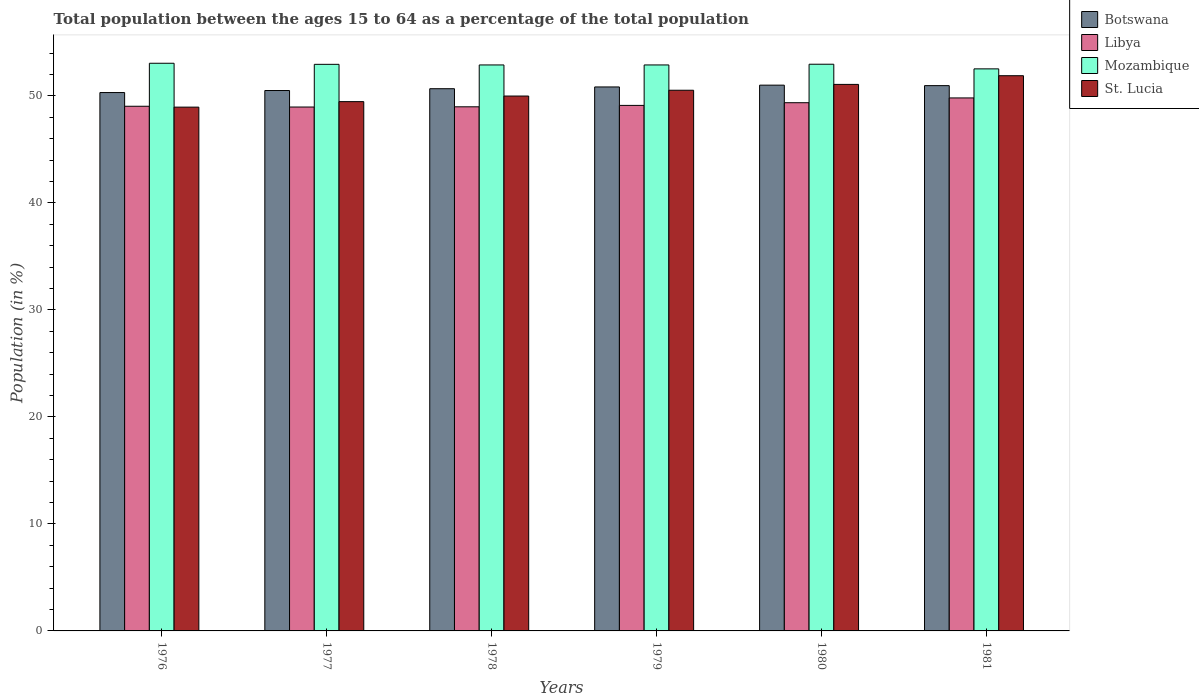How many different coloured bars are there?
Offer a terse response. 4. How many bars are there on the 6th tick from the right?
Your answer should be very brief. 4. What is the label of the 4th group of bars from the left?
Your answer should be compact. 1979. In how many cases, is the number of bars for a given year not equal to the number of legend labels?
Offer a very short reply. 0. What is the percentage of the population ages 15 to 64 in Mozambique in 1976?
Your answer should be compact. 53.05. Across all years, what is the maximum percentage of the population ages 15 to 64 in Libya?
Your answer should be compact. 49.81. Across all years, what is the minimum percentage of the population ages 15 to 64 in Mozambique?
Ensure brevity in your answer.  52.53. In which year was the percentage of the population ages 15 to 64 in Libya maximum?
Give a very brief answer. 1981. What is the total percentage of the population ages 15 to 64 in St. Lucia in the graph?
Provide a short and direct response. 301.91. What is the difference between the percentage of the population ages 15 to 64 in Libya in 1978 and that in 1979?
Offer a very short reply. -0.13. What is the difference between the percentage of the population ages 15 to 64 in Mozambique in 1977 and the percentage of the population ages 15 to 64 in Botswana in 1978?
Your answer should be compact. 2.28. What is the average percentage of the population ages 15 to 64 in St. Lucia per year?
Provide a succinct answer. 50.32. In the year 1977, what is the difference between the percentage of the population ages 15 to 64 in Botswana and percentage of the population ages 15 to 64 in St. Lucia?
Your answer should be compact. 1.04. In how many years, is the percentage of the population ages 15 to 64 in St. Lucia greater than 46?
Keep it short and to the point. 6. What is the ratio of the percentage of the population ages 15 to 64 in Mozambique in 1978 to that in 1981?
Offer a terse response. 1.01. What is the difference between the highest and the second highest percentage of the population ages 15 to 64 in Botswana?
Offer a very short reply. 0.05. What is the difference between the highest and the lowest percentage of the population ages 15 to 64 in Mozambique?
Provide a short and direct response. 0.52. In how many years, is the percentage of the population ages 15 to 64 in Mozambique greater than the average percentage of the population ages 15 to 64 in Mozambique taken over all years?
Make the answer very short. 5. Is it the case that in every year, the sum of the percentage of the population ages 15 to 64 in St. Lucia and percentage of the population ages 15 to 64 in Libya is greater than the sum of percentage of the population ages 15 to 64 in Botswana and percentage of the population ages 15 to 64 in Mozambique?
Your answer should be very brief. No. What does the 1st bar from the left in 1979 represents?
Keep it short and to the point. Botswana. What does the 3rd bar from the right in 1980 represents?
Your response must be concise. Libya. Is it the case that in every year, the sum of the percentage of the population ages 15 to 64 in St. Lucia and percentage of the population ages 15 to 64 in Libya is greater than the percentage of the population ages 15 to 64 in Mozambique?
Your answer should be compact. Yes. How many bars are there?
Your response must be concise. 24. What is the difference between two consecutive major ticks on the Y-axis?
Your answer should be very brief. 10. Are the values on the major ticks of Y-axis written in scientific E-notation?
Make the answer very short. No. What is the title of the graph?
Your response must be concise. Total population between the ages 15 to 64 as a percentage of the total population. Does "Albania" appear as one of the legend labels in the graph?
Provide a short and direct response. No. What is the label or title of the X-axis?
Provide a short and direct response. Years. What is the label or title of the Y-axis?
Ensure brevity in your answer.  Population (in %). What is the Population (in %) of Botswana in 1976?
Your response must be concise. 50.32. What is the Population (in %) in Libya in 1976?
Your response must be concise. 49.03. What is the Population (in %) in Mozambique in 1976?
Offer a terse response. 53.05. What is the Population (in %) of St. Lucia in 1976?
Keep it short and to the point. 48.95. What is the Population (in %) in Botswana in 1977?
Your answer should be compact. 50.51. What is the Population (in %) of Libya in 1977?
Your answer should be very brief. 48.96. What is the Population (in %) in Mozambique in 1977?
Provide a short and direct response. 52.95. What is the Population (in %) in St. Lucia in 1977?
Your response must be concise. 49.47. What is the Population (in %) of Botswana in 1978?
Your response must be concise. 50.68. What is the Population (in %) of Libya in 1978?
Give a very brief answer. 48.98. What is the Population (in %) in Mozambique in 1978?
Provide a succinct answer. 52.9. What is the Population (in %) of St. Lucia in 1978?
Your response must be concise. 49.99. What is the Population (in %) in Botswana in 1979?
Provide a succinct answer. 50.84. What is the Population (in %) in Libya in 1979?
Make the answer very short. 49.12. What is the Population (in %) in Mozambique in 1979?
Your answer should be very brief. 52.9. What is the Population (in %) in St. Lucia in 1979?
Ensure brevity in your answer.  50.53. What is the Population (in %) of Botswana in 1980?
Provide a succinct answer. 51.01. What is the Population (in %) in Libya in 1980?
Ensure brevity in your answer.  49.37. What is the Population (in %) in Mozambique in 1980?
Make the answer very short. 52.96. What is the Population (in %) in St. Lucia in 1980?
Offer a very short reply. 51.08. What is the Population (in %) of Botswana in 1981?
Offer a terse response. 50.96. What is the Population (in %) in Libya in 1981?
Offer a very short reply. 49.81. What is the Population (in %) in Mozambique in 1981?
Offer a very short reply. 52.53. What is the Population (in %) of St. Lucia in 1981?
Give a very brief answer. 51.89. Across all years, what is the maximum Population (in %) in Botswana?
Provide a short and direct response. 51.01. Across all years, what is the maximum Population (in %) of Libya?
Ensure brevity in your answer.  49.81. Across all years, what is the maximum Population (in %) in Mozambique?
Offer a very short reply. 53.05. Across all years, what is the maximum Population (in %) in St. Lucia?
Give a very brief answer. 51.89. Across all years, what is the minimum Population (in %) in Botswana?
Offer a terse response. 50.32. Across all years, what is the minimum Population (in %) of Libya?
Your answer should be compact. 48.96. Across all years, what is the minimum Population (in %) in Mozambique?
Give a very brief answer. 52.53. Across all years, what is the minimum Population (in %) of St. Lucia?
Give a very brief answer. 48.95. What is the total Population (in %) in Botswana in the graph?
Provide a short and direct response. 304.31. What is the total Population (in %) in Libya in the graph?
Ensure brevity in your answer.  295.28. What is the total Population (in %) of Mozambique in the graph?
Offer a very short reply. 317.29. What is the total Population (in %) in St. Lucia in the graph?
Offer a terse response. 301.91. What is the difference between the Population (in %) of Botswana in 1976 and that in 1977?
Provide a short and direct response. -0.19. What is the difference between the Population (in %) in Libya in 1976 and that in 1977?
Give a very brief answer. 0.07. What is the difference between the Population (in %) in Mozambique in 1976 and that in 1977?
Keep it short and to the point. 0.1. What is the difference between the Population (in %) in St. Lucia in 1976 and that in 1977?
Your answer should be compact. -0.51. What is the difference between the Population (in %) in Botswana in 1976 and that in 1978?
Offer a terse response. -0.36. What is the difference between the Population (in %) in Libya in 1976 and that in 1978?
Your answer should be compact. 0.05. What is the difference between the Population (in %) of Mozambique in 1976 and that in 1978?
Offer a very short reply. 0.16. What is the difference between the Population (in %) of St. Lucia in 1976 and that in 1978?
Your response must be concise. -1.04. What is the difference between the Population (in %) of Botswana in 1976 and that in 1979?
Your answer should be very brief. -0.52. What is the difference between the Population (in %) in Libya in 1976 and that in 1979?
Your response must be concise. -0.08. What is the difference between the Population (in %) in Mozambique in 1976 and that in 1979?
Provide a succinct answer. 0.16. What is the difference between the Population (in %) of St. Lucia in 1976 and that in 1979?
Provide a succinct answer. -1.58. What is the difference between the Population (in %) of Botswana in 1976 and that in 1980?
Ensure brevity in your answer.  -0.69. What is the difference between the Population (in %) of Libya in 1976 and that in 1980?
Your answer should be very brief. -0.33. What is the difference between the Population (in %) of Mozambique in 1976 and that in 1980?
Give a very brief answer. 0.09. What is the difference between the Population (in %) of St. Lucia in 1976 and that in 1980?
Make the answer very short. -2.13. What is the difference between the Population (in %) in Botswana in 1976 and that in 1981?
Your answer should be very brief. -0.65. What is the difference between the Population (in %) of Libya in 1976 and that in 1981?
Your response must be concise. -0.78. What is the difference between the Population (in %) in Mozambique in 1976 and that in 1981?
Provide a succinct answer. 0.52. What is the difference between the Population (in %) of St. Lucia in 1976 and that in 1981?
Provide a succinct answer. -2.94. What is the difference between the Population (in %) in Botswana in 1977 and that in 1978?
Provide a succinct answer. -0.17. What is the difference between the Population (in %) of Libya in 1977 and that in 1978?
Your response must be concise. -0.02. What is the difference between the Population (in %) in Mozambique in 1977 and that in 1978?
Keep it short and to the point. 0.06. What is the difference between the Population (in %) of St. Lucia in 1977 and that in 1978?
Offer a very short reply. -0.52. What is the difference between the Population (in %) of Botswana in 1977 and that in 1979?
Keep it short and to the point. -0.33. What is the difference between the Population (in %) in Libya in 1977 and that in 1979?
Your response must be concise. -0.15. What is the difference between the Population (in %) in Mozambique in 1977 and that in 1979?
Provide a short and direct response. 0.06. What is the difference between the Population (in %) of St. Lucia in 1977 and that in 1979?
Your answer should be compact. -1.06. What is the difference between the Population (in %) in Botswana in 1977 and that in 1980?
Your answer should be compact. -0.5. What is the difference between the Population (in %) in Libya in 1977 and that in 1980?
Your response must be concise. -0.4. What is the difference between the Population (in %) in Mozambique in 1977 and that in 1980?
Your answer should be compact. -0.01. What is the difference between the Population (in %) in St. Lucia in 1977 and that in 1980?
Give a very brief answer. -1.61. What is the difference between the Population (in %) of Botswana in 1977 and that in 1981?
Ensure brevity in your answer.  -0.46. What is the difference between the Population (in %) of Libya in 1977 and that in 1981?
Provide a succinct answer. -0.85. What is the difference between the Population (in %) of Mozambique in 1977 and that in 1981?
Keep it short and to the point. 0.42. What is the difference between the Population (in %) in St. Lucia in 1977 and that in 1981?
Your answer should be very brief. -2.42. What is the difference between the Population (in %) of Botswana in 1978 and that in 1979?
Your response must be concise. -0.16. What is the difference between the Population (in %) in Libya in 1978 and that in 1979?
Give a very brief answer. -0.13. What is the difference between the Population (in %) of Mozambique in 1978 and that in 1979?
Provide a short and direct response. -0. What is the difference between the Population (in %) of St. Lucia in 1978 and that in 1979?
Your answer should be very brief. -0.54. What is the difference between the Population (in %) of Botswana in 1978 and that in 1980?
Your answer should be compact. -0.33. What is the difference between the Population (in %) in Libya in 1978 and that in 1980?
Give a very brief answer. -0.38. What is the difference between the Population (in %) of Mozambique in 1978 and that in 1980?
Your answer should be compact. -0.07. What is the difference between the Population (in %) of St. Lucia in 1978 and that in 1980?
Your answer should be compact. -1.09. What is the difference between the Population (in %) in Botswana in 1978 and that in 1981?
Your answer should be compact. -0.29. What is the difference between the Population (in %) of Libya in 1978 and that in 1981?
Provide a short and direct response. -0.83. What is the difference between the Population (in %) of Mozambique in 1978 and that in 1981?
Keep it short and to the point. 0.37. What is the difference between the Population (in %) in St. Lucia in 1978 and that in 1981?
Offer a very short reply. -1.9. What is the difference between the Population (in %) of Botswana in 1979 and that in 1980?
Keep it short and to the point. -0.17. What is the difference between the Population (in %) in Libya in 1979 and that in 1980?
Give a very brief answer. -0.25. What is the difference between the Population (in %) of Mozambique in 1979 and that in 1980?
Your answer should be compact. -0.07. What is the difference between the Population (in %) of St. Lucia in 1979 and that in 1980?
Offer a terse response. -0.55. What is the difference between the Population (in %) of Botswana in 1979 and that in 1981?
Give a very brief answer. -0.12. What is the difference between the Population (in %) of Libya in 1979 and that in 1981?
Provide a short and direct response. -0.7. What is the difference between the Population (in %) in Mozambique in 1979 and that in 1981?
Keep it short and to the point. 0.37. What is the difference between the Population (in %) of St. Lucia in 1979 and that in 1981?
Provide a short and direct response. -1.36. What is the difference between the Population (in %) of Botswana in 1980 and that in 1981?
Your response must be concise. 0.05. What is the difference between the Population (in %) in Libya in 1980 and that in 1981?
Give a very brief answer. -0.45. What is the difference between the Population (in %) in Mozambique in 1980 and that in 1981?
Offer a very short reply. 0.43. What is the difference between the Population (in %) of St. Lucia in 1980 and that in 1981?
Your answer should be very brief. -0.81. What is the difference between the Population (in %) in Botswana in 1976 and the Population (in %) in Libya in 1977?
Offer a terse response. 1.35. What is the difference between the Population (in %) in Botswana in 1976 and the Population (in %) in Mozambique in 1977?
Your response must be concise. -2.64. What is the difference between the Population (in %) of Botswana in 1976 and the Population (in %) of St. Lucia in 1977?
Give a very brief answer. 0.85. What is the difference between the Population (in %) in Libya in 1976 and the Population (in %) in Mozambique in 1977?
Ensure brevity in your answer.  -3.92. What is the difference between the Population (in %) of Libya in 1976 and the Population (in %) of St. Lucia in 1977?
Ensure brevity in your answer.  -0.43. What is the difference between the Population (in %) of Mozambique in 1976 and the Population (in %) of St. Lucia in 1977?
Keep it short and to the point. 3.59. What is the difference between the Population (in %) in Botswana in 1976 and the Population (in %) in Libya in 1978?
Your answer should be compact. 1.33. What is the difference between the Population (in %) in Botswana in 1976 and the Population (in %) in Mozambique in 1978?
Your response must be concise. -2.58. What is the difference between the Population (in %) in Botswana in 1976 and the Population (in %) in St. Lucia in 1978?
Give a very brief answer. 0.33. What is the difference between the Population (in %) of Libya in 1976 and the Population (in %) of Mozambique in 1978?
Provide a short and direct response. -3.86. What is the difference between the Population (in %) of Libya in 1976 and the Population (in %) of St. Lucia in 1978?
Ensure brevity in your answer.  -0.96. What is the difference between the Population (in %) of Mozambique in 1976 and the Population (in %) of St. Lucia in 1978?
Give a very brief answer. 3.06. What is the difference between the Population (in %) in Botswana in 1976 and the Population (in %) in Libya in 1979?
Your answer should be very brief. 1.2. What is the difference between the Population (in %) in Botswana in 1976 and the Population (in %) in Mozambique in 1979?
Make the answer very short. -2.58. What is the difference between the Population (in %) in Botswana in 1976 and the Population (in %) in St. Lucia in 1979?
Provide a short and direct response. -0.22. What is the difference between the Population (in %) of Libya in 1976 and the Population (in %) of Mozambique in 1979?
Give a very brief answer. -3.86. What is the difference between the Population (in %) of Libya in 1976 and the Population (in %) of St. Lucia in 1979?
Give a very brief answer. -1.5. What is the difference between the Population (in %) in Mozambique in 1976 and the Population (in %) in St. Lucia in 1979?
Keep it short and to the point. 2.52. What is the difference between the Population (in %) in Botswana in 1976 and the Population (in %) in Libya in 1980?
Your response must be concise. 0.95. What is the difference between the Population (in %) in Botswana in 1976 and the Population (in %) in Mozambique in 1980?
Provide a succinct answer. -2.65. What is the difference between the Population (in %) of Botswana in 1976 and the Population (in %) of St. Lucia in 1980?
Offer a very short reply. -0.76. What is the difference between the Population (in %) in Libya in 1976 and the Population (in %) in Mozambique in 1980?
Ensure brevity in your answer.  -3.93. What is the difference between the Population (in %) of Libya in 1976 and the Population (in %) of St. Lucia in 1980?
Ensure brevity in your answer.  -2.04. What is the difference between the Population (in %) of Mozambique in 1976 and the Population (in %) of St. Lucia in 1980?
Offer a terse response. 1.98. What is the difference between the Population (in %) of Botswana in 1976 and the Population (in %) of Libya in 1981?
Give a very brief answer. 0.5. What is the difference between the Population (in %) of Botswana in 1976 and the Population (in %) of Mozambique in 1981?
Provide a short and direct response. -2.21. What is the difference between the Population (in %) in Botswana in 1976 and the Population (in %) in St. Lucia in 1981?
Your answer should be very brief. -1.57. What is the difference between the Population (in %) in Libya in 1976 and the Population (in %) in Mozambique in 1981?
Your answer should be compact. -3.49. What is the difference between the Population (in %) of Libya in 1976 and the Population (in %) of St. Lucia in 1981?
Ensure brevity in your answer.  -2.86. What is the difference between the Population (in %) in Mozambique in 1976 and the Population (in %) in St. Lucia in 1981?
Give a very brief answer. 1.16. What is the difference between the Population (in %) in Botswana in 1977 and the Population (in %) in Libya in 1978?
Make the answer very short. 1.52. What is the difference between the Population (in %) of Botswana in 1977 and the Population (in %) of Mozambique in 1978?
Make the answer very short. -2.39. What is the difference between the Population (in %) of Botswana in 1977 and the Population (in %) of St. Lucia in 1978?
Keep it short and to the point. 0.52. What is the difference between the Population (in %) of Libya in 1977 and the Population (in %) of Mozambique in 1978?
Your answer should be compact. -3.93. What is the difference between the Population (in %) in Libya in 1977 and the Population (in %) in St. Lucia in 1978?
Your answer should be compact. -1.03. What is the difference between the Population (in %) of Mozambique in 1977 and the Population (in %) of St. Lucia in 1978?
Your answer should be very brief. 2.96. What is the difference between the Population (in %) of Botswana in 1977 and the Population (in %) of Libya in 1979?
Your answer should be very brief. 1.39. What is the difference between the Population (in %) in Botswana in 1977 and the Population (in %) in Mozambique in 1979?
Offer a very short reply. -2.39. What is the difference between the Population (in %) of Botswana in 1977 and the Population (in %) of St. Lucia in 1979?
Offer a terse response. -0.03. What is the difference between the Population (in %) of Libya in 1977 and the Population (in %) of Mozambique in 1979?
Offer a very short reply. -3.93. What is the difference between the Population (in %) in Libya in 1977 and the Population (in %) in St. Lucia in 1979?
Give a very brief answer. -1.57. What is the difference between the Population (in %) of Mozambique in 1977 and the Population (in %) of St. Lucia in 1979?
Your response must be concise. 2.42. What is the difference between the Population (in %) of Botswana in 1977 and the Population (in %) of Libya in 1980?
Your answer should be compact. 1.14. What is the difference between the Population (in %) in Botswana in 1977 and the Population (in %) in Mozambique in 1980?
Your answer should be compact. -2.46. What is the difference between the Population (in %) of Botswana in 1977 and the Population (in %) of St. Lucia in 1980?
Offer a very short reply. -0.57. What is the difference between the Population (in %) in Libya in 1977 and the Population (in %) in Mozambique in 1980?
Make the answer very short. -4. What is the difference between the Population (in %) in Libya in 1977 and the Population (in %) in St. Lucia in 1980?
Provide a short and direct response. -2.11. What is the difference between the Population (in %) in Mozambique in 1977 and the Population (in %) in St. Lucia in 1980?
Your response must be concise. 1.88. What is the difference between the Population (in %) of Botswana in 1977 and the Population (in %) of Libya in 1981?
Offer a terse response. 0.69. What is the difference between the Population (in %) of Botswana in 1977 and the Population (in %) of Mozambique in 1981?
Your answer should be very brief. -2.02. What is the difference between the Population (in %) in Botswana in 1977 and the Population (in %) in St. Lucia in 1981?
Offer a very short reply. -1.38. What is the difference between the Population (in %) in Libya in 1977 and the Population (in %) in Mozambique in 1981?
Keep it short and to the point. -3.57. What is the difference between the Population (in %) of Libya in 1977 and the Population (in %) of St. Lucia in 1981?
Make the answer very short. -2.93. What is the difference between the Population (in %) in Mozambique in 1977 and the Population (in %) in St. Lucia in 1981?
Your answer should be compact. 1.06. What is the difference between the Population (in %) of Botswana in 1978 and the Population (in %) of Libya in 1979?
Provide a succinct answer. 1.56. What is the difference between the Population (in %) of Botswana in 1978 and the Population (in %) of Mozambique in 1979?
Your answer should be compact. -2.22. What is the difference between the Population (in %) of Botswana in 1978 and the Population (in %) of St. Lucia in 1979?
Provide a short and direct response. 0.14. What is the difference between the Population (in %) of Libya in 1978 and the Population (in %) of Mozambique in 1979?
Your answer should be compact. -3.91. What is the difference between the Population (in %) of Libya in 1978 and the Population (in %) of St. Lucia in 1979?
Provide a succinct answer. -1.55. What is the difference between the Population (in %) in Mozambique in 1978 and the Population (in %) in St. Lucia in 1979?
Offer a very short reply. 2.36. What is the difference between the Population (in %) of Botswana in 1978 and the Population (in %) of Libya in 1980?
Make the answer very short. 1.31. What is the difference between the Population (in %) of Botswana in 1978 and the Population (in %) of Mozambique in 1980?
Offer a terse response. -2.29. What is the difference between the Population (in %) in Botswana in 1978 and the Population (in %) in St. Lucia in 1980?
Offer a terse response. -0.4. What is the difference between the Population (in %) in Libya in 1978 and the Population (in %) in Mozambique in 1980?
Make the answer very short. -3.98. What is the difference between the Population (in %) in Libya in 1978 and the Population (in %) in St. Lucia in 1980?
Provide a short and direct response. -2.09. What is the difference between the Population (in %) of Mozambique in 1978 and the Population (in %) of St. Lucia in 1980?
Provide a short and direct response. 1.82. What is the difference between the Population (in %) in Botswana in 1978 and the Population (in %) in Libya in 1981?
Offer a terse response. 0.86. What is the difference between the Population (in %) in Botswana in 1978 and the Population (in %) in Mozambique in 1981?
Provide a succinct answer. -1.85. What is the difference between the Population (in %) in Botswana in 1978 and the Population (in %) in St. Lucia in 1981?
Give a very brief answer. -1.21. What is the difference between the Population (in %) of Libya in 1978 and the Population (in %) of Mozambique in 1981?
Your answer should be very brief. -3.54. What is the difference between the Population (in %) of Libya in 1978 and the Population (in %) of St. Lucia in 1981?
Offer a terse response. -2.91. What is the difference between the Population (in %) in Mozambique in 1978 and the Population (in %) in St. Lucia in 1981?
Offer a terse response. 1.01. What is the difference between the Population (in %) in Botswana in 1979 and the Population (in %) in Libya in 1980?
Give a very brief answer. 1.47. What is the difference between the Population (in %) of Botswana in 1979 and the Population (in %) of Mozambique in 1980?
Keep it short and to the point. -2.12. What is the difference between the Population (in %) of Botswana in 1979 and the Population (in %) of St. Lucia in 1980?
Your answer should be compact. -0.24. What is the difference between the Population (in %) of Libya in 1979 and the Population (in %) of Mozambique in 1980?
Ensure brevity in your answer.  -3.85. What is the difference between the Population (in %) in Libya in 1979 and the Population (in %) in St. Lucia in 1980?
Ensure brevity in your answer.  -1.96. What is the difference between the Population (in %) of Mozambique in 1979 and the Population (in %) of St. Lucia in 1980?
Your answer should be very brief. 1.82. What is the difference between the Population (in %) of Botswana in 1979 and the Population (in %) of Libya in 1981?
Ensure brevity in your answer.  1.03. What is the difference between the Population (in %) in Botswana in 1979 and the Population (in %) in Mozambique in 1981?
Your answer should be compact. -1.69. What is the difference between the Population (in %) in Botswana in 1979 and the Population (in %) in St. Lucia in 1981?
Ensure brevity in your answer.  -1.05. What is the difference between the Population (in %) of Libya in 1979 and the Population (in %) of Mozambique in 1981?
Provide a succinct answer. -3.41. What is the difference between the Population (in %) in Libya in 1979 and the Population (in %) in St. Lucia in 1981?
Your answer should be very brief. -2.77. What is the difference between the Population (in %) of Mozambique in 1979 and the Population (in %) of St. Lucia in 1981?
Ensure brevity in your answer.  1.01. What is the difference between the Population (in %) of Botswana in 1980 and the Population (in %) of Libya in 1981?
Offer a very short reply. 1.19. What is the difference between the Population (in %) of Botswana in 1980 and the Population (in %) of Mozambique in 1981?
Your answer should be compact. -1.52. What is the difference between the Population (in %) in Botswana in 1980 and the Population (in %) in St. Lucia in 1981?
Keep it short and to the point. -0.88. What is the difference between the Population (in %) of Libya in 1980 and the Population (in %) of Mozambique in 1981?
Give a very brief answer. -3.16. What is the difference between the Population (in %) in Libya in 1980 and the Population (in %) in St. Lucia in 1981?
Your response must be concise. -2.52. What is the difference between the Population (in %) in Mozambique in 1980 and the Population (in %) in St. Lucia in 1981?
Your response must be concise. 1.07. What is the average Population (in %) of Botswana per year?
Your response must be concise. 50.72. What is the average Population (in %) in Libya per year?
Ensure brevity in your answer.  49.21. What is the average Population (in %) in Mozambique per year?
Provide a short and direct response. 52.88. What is the average Population (in %) in St. Lucia per year?
Provide a succinct answer. 50.32. In the year 1976, what is the difference between the Population (in %) in Botswana and Population (in %) in Libya?
Offer a terse response. 1.28. In the year 1976, what is the difference between the Population (in %) of Botswana and Population (in %) of Mozambique?
Provide a succinct answer. -2.74. In the year 1976, what is the difference between the Population (in %) in Botswana and Population (in %) in St. Lucia?
Make the answer very short. 1.36. In the year 1976, what is the difference between the Population (in %) in Libya and Population (in %) in Mozambique?
Provide a short and direct response. -4.02. In the year 1976, what is the difference between the Population (in %) in Libya and Population (in %) in St. Lucia?
Your response must be concise. 0.08. In the year 1976, what is the difference between the Population (in %) in Mozambique and Population (in %) in St. Lucia?
Make the answer very short. 4.1. In the year 1977, what is the difference between the Population (in %) of Botswana and Population (in %) of Libya?
Provide a short and direct response. 1.54. In the year 1977, what is the difference between the Population (in %) in Botswana and Population (in %) in Mozambique?
Offer a terse response. -2.45. In the year 1977, what is the difference between the Population (in %) of Botswana and Population (in %) of St. Lucia?
Your response must be concise. 1.04. In the year 1977, what is the difference between the Population (in %) of Libya and Population (in %) of Mozambique?
Offer a terse response. -3.99. In the year 1977, what is the difference between the Population (in %) of Libya and Population (in %) of St. Lucia?
Offer a very short reply. -0.5. In the year 1977, what is the difference between the Population (in %) in Mozambique and Population (in %) in St. Lucia?
Your response must be concise. 3.49. In the year 1978, what is the difference between the Population (in %) of Botswana and Population (in %) of Libya?
Your answer should be compact. 1.69. In the year 1978, what is the difference between the Population (in %) of Botswana and Population (in %) of Mozambique?
Provide a short and direct response. -2.22. In the year 1978, what is the difference between the Population (in %) of Botswana and Population (in %) of St. Lucia?
Offer a very short reply. 0.69. In the year 1978, what is the difference between the Population (in %) of Libya and Population (in %) of Mozambique?
Provide a short and direct response. -3.91. In the year 1978, what is the difference between the Population (in %) of Libya and Population (in %) of St. Lucia?
Your answer should be very brief. -1.01. In the year 1978, what is the difference between the Population (in %) of Mozambique and Population (in %) of St. Lucia?
Give a very brief answer. 2.91. In the year 1979, what is the difference between the Population (in %) in Botswana and Population (in %) in Libya?
Keep it short and to the point. 1.72. In the year 1979, what is the difference between the Population (in %) of Botswana and Population (in %) of Mozambique?
Provide a short and direct response. -2.06. In the year 1979, what is the difference between the Population (in %) in Botswana and Population (in %) in St. Lucia?
Your response must be concise. 0.31. In the year 1979, what is the difference between the Population (in %) of Libya and Population (in %) of Mozambique?
Make the answer very short. -3.78. In the year 1979, what is the difference between the Population (in %) of Libya and Population (in %) of St. Lucia?
Keep it short and to the point. -1.42. In the year 1979, what is the difference between the Population (in %) in Mozambique and Population (in %) in St. Lucia?
Make the answer very short. 2.36. In the year 1980, what is the difference between the Population (in %) in Botswana and Population (in %) in Libya?
Make the answer very short. 1.64. In the year 1980, what is the difference between the Population (in %) of Botswana and Population (in %) of Mozambique?
Provide a short and direct response. -1.96. In the year 1980, what is the difference between the Population (in %) of Botswana and Population (in %) of St. Lucia?
Your answer should be very brief. -0.07. In the year 1980, what is the difference between the Population (in %) in Libya and Population (in %) in Mozambique?
Offer a terse response. -3.6. In the year 1980, what is the difference between the Population (in %) of Libya and Population (in %) of St. Lucia?
Your answer should be very brief. -1.71. In the year 1980, what is the difference between the Population (in %) of Mozambique and Population (in %) of St. Lucia?
Keep it short and to the point. 1.89. In the year 1981, what is the difference between the Population (in %) in Botswana and Population (in %) in Libya?
Offer a terse response. 1.15. In the year 1981, what is the difference between the Population (in %) of Botswana and Population (in %) of Mozambique?
Your answer should be compact. -1.57. In the year 1981, what is the difference between the Population (in %) in Botswana and Population (in %) in St. Lucia?
Your response must be concise. -0.93. In the year 1981, what is the difference between the Population (in %) of Libya and Population (in %) of Mozambique?
Offer a terse response. -2.72. In the year 1981, what is the difference between the Population (in %) in Libya and Population (in %) in St. Lucia?
Offer a terse response. -2.08. In the year 1981, what is the difference between the Population (in %) of Mozambique and Population (in %) of St. Lucia?
Make the answer very short. 0.64. What is the ratio of the Population (in %) of Botswana in 1976 to that in 1977?
Your answer should be compact. 1. What is the ratio of the Population (in %) in Libya in 1976 to that in 1977?
Offer a very short reply. 1. What is the ratio of the Population (in %) in Mozambique in 1976 to that in 1977?
Make the answer very short. 1. What is the ratio of the Population (in %) in Botswana in 1976 to that in 1978?
Your answer should be compact. 0.99. What is the ratio of the Population (in %) of Mozambique in 1976 to that in 1978?
Provide a succinct answer. 1. What is the ratio of the Population (in %) in St. Lucia in 1976 to that in 1978?
Your answer should be very brief. 0.98. What is the ratio of the Population (in %) in Botswana in 1976 to that in 1979?
Your response must be concise. 0.99. What is the ratio of the Population (in %) in Libya in 1976 to that in 1979?
Your response must be concise. 1. What is the ratio of the Population (in %) in St. Lucia in 1976 to that in 1979?
Your answer should be compact. 0.97. What is the ratio of the Population (in %) of Botswana in 1976 to that in 1980?
Make the answer very short. 0.99. What is the ratio of the Population (in %) in Mozambique in 1976 to that in 1980?
Offer a very short reply. 1. What is the ratio of the Population (in %) in St. Lucia in 1976 to that in 1980?
Give a very brief answer. 0.96. What is the ratio of the Population (in %) of Botswana in 1976 to that in 1981?
Make the answer very short. 0.99. What is the ratio of the Population (in %) in Libya in 1976 to that in 1981?
Make the answer very short. 0.98. What is the ratio of the Population (in %) in Mozambique in 1976 to that in 1981?
Your response must be concise. 1.01. What is the ratio of the Population (in %) in St. Lucia in 1976 to that in 1981?
Provide a succinct answer. 0.94. What is the ratio of the Population (in %) in Botswana in 1977 to that in 1978?
Give a very brief answer. 1. What is the ratio of the Population (in %) in St. Lucia in 1977 to that in 1978?
Your response must be concise. 0.99. What is the ratio of the Population (in %) in Botswana in 1977 to that in 1979?
Your answer should be very brief. 0.99. What is the ratio of the Population (in %) in St. Lucia in 1977 to that in 1979?
Give a very brief answer. 0.98. What is the ratio of the Population (in %) of Libya in 1977 to that in 1980?
Give a very brief answer. 0.99. What is the ratio of the Population (in %) of Mozambique in 1977 to that in 1980?
Give a very brief answer. 1. What is the ratio of the Population (in %) in St. Lucia in 1977 to that in 1980?
Keep it short and to the point. 0.97. What is the ratio of the Population (in %) in Libya in 1977 to that in 1981?
Provide a succinct answer. 0.98. What is the ratio of the Population (in %) of St. Lucia in 1977 to that in 1981?
Ensure brevity in your answer.  0.95. What is the ratio of the Population (in %) in Botswana in 1978 to that in 1979?
Keep it short and to the point. 1. What is the ratio of the Population (in %) in Libya in 1978 to that in 1979?
Provide a succinct answer. 1. What is the ratio of the Population (in %) in Mozambique in 1978 to that in 1979?
Your response must be concise. 1. What is the ratio of the Population (in %) of St. Lucia in 1978 to that in 1979?
Keep it short and to the point. 0.99. What is the ratio of the Population (in %) of St. Lucia in 1978 to that in 1980?
Your response must be concise. 0.98. What is the ratio of the Population (in %) of Botswana in 1978 to that in 1981?
Ensure brevity in your answer.  0.99. What is the ratio of the Population (in %) in Libya in 1978 to that in 1981?
Provide a succinct answer. 0.98. What is the ratio of the Population (in %) in Mozambique in 1978 to that in 1981?
Offer a very short reply. 1.01. What is the ratio of the Population (in %) in St. Lucia in 1978 to that in 1981?
Provide a succinct answer. 0.96. What is the ratio of the Population (in %) in Botswana in 1979 to that in 1980?
Offer a very short reply. 1. What is the ratio of the Population (in %) of Mozambique in 1979 to that in 1980?
Your response must be concise. 1. What is the ratio of the Population (in %) in St. Lucia in 1979 to that in 1980?
Give a very brief answer. 0.99. What is the ratio of the Population (in %) in Libya in 1979 to that in 1981?
Make the answer very short. 0.99. What is the ratio of the Population (in %) of Mozambique in 1979 to that in 1981?
Ensure brevity in your answer.  1.01. What is the ratio of the Population (in %) of St. Lucia in 1979 to that in 1981?
Provide a succinct answer. 0.97. What is the ratio of the Population (in %) in Botswana in 1980 to that in 1981?
Make the answer very short. 1. What is the ratio of the Population (in %) in Libya in 1980 to that in 1981?
Your answer should be very brief. 0.99. What is the ratio of the Population (in %) in Mozambique in 1980 to that in 1981?
Provide a short and direct response. 1.01. What is the ratio of the Population (in %) of St. Lucia in 1980 to that in 1981?
Your answer should be compact. 0.98. What is the difference between the highest and the second highest Population (in %) in Botswana?
Offer a terse response. 0.05. What is the difference between the highest and the second highest Population (in %) of Libya?
Provide a succinct answer. 0.45. What is the difference between the highest and the second highest Population (in %) in Mozambique?
Offer a very short reply. 0.09. What is the difference between the highest and the second highest Population (in %) of St. Lucia?
Make the answer very short. 0.81. What is the difference between the highest and the lowest Population (in %) of Botswana?
Your answer should be very brief. 0.69. What is the difference between the highest and the lowest Population (in %) of Libya?
Your answer should be very brief. 0.85. What is the difference between the highest and the lowest Population (in %) of Mozambique?
Provide a succinct answer. 0.52. What is the difference between the highest and the lowest Population (in %) in St. Lucia?
Offer a terse response. 2.94. 